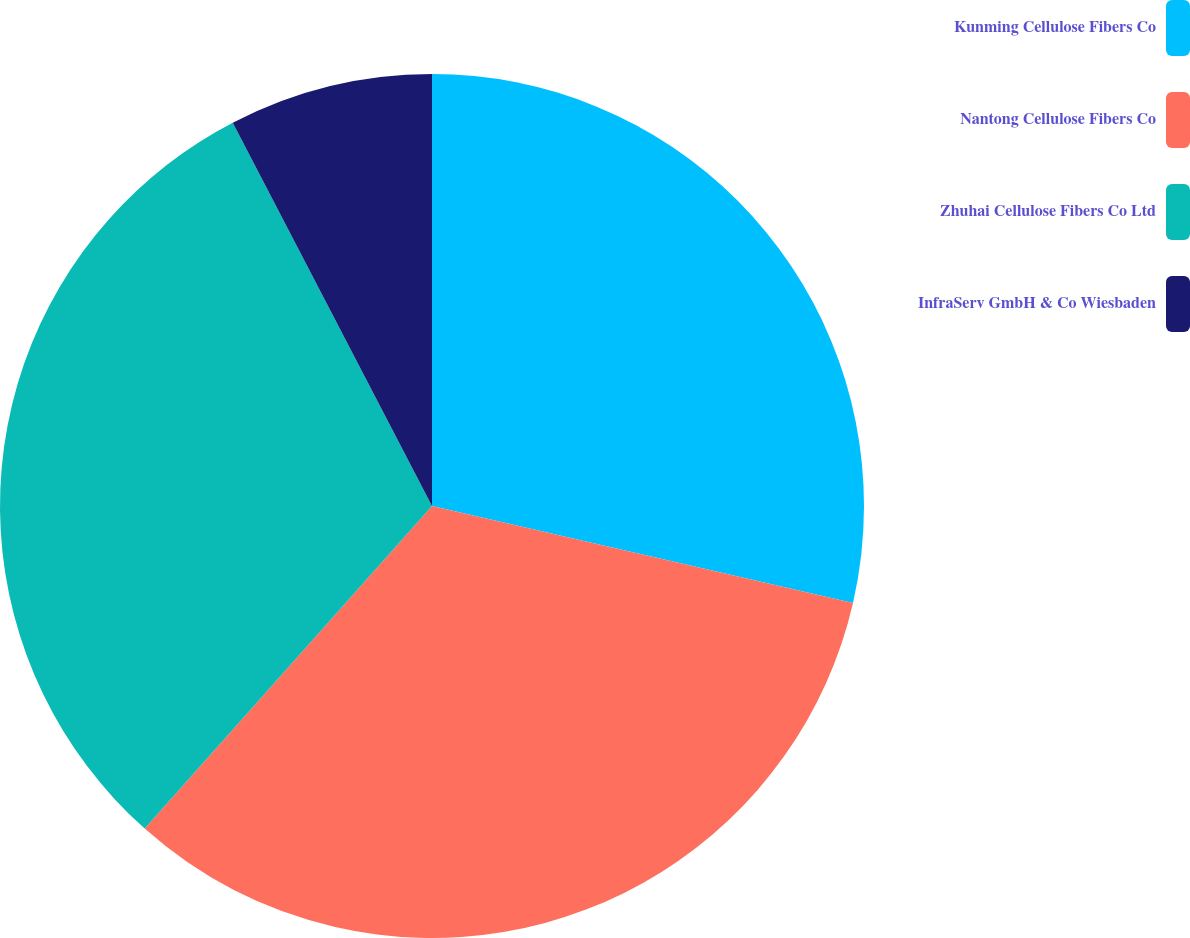Convert chart. <chart><loc_0><loc_0><loc_500><loc_500><pie_chart><fcel>Kunming Cellulose Fibers Co<fcel>Nantong Cellulose Fibers Co<fcel>Zhuhai Cellulose Fibers Co Ltd<fcel>InfraServ GmbH & Co Wiesbaden<nl><fcel>28.6%<fcel>32.98%<fcel>30.79%<fcel>7.63%<nl></chart> 